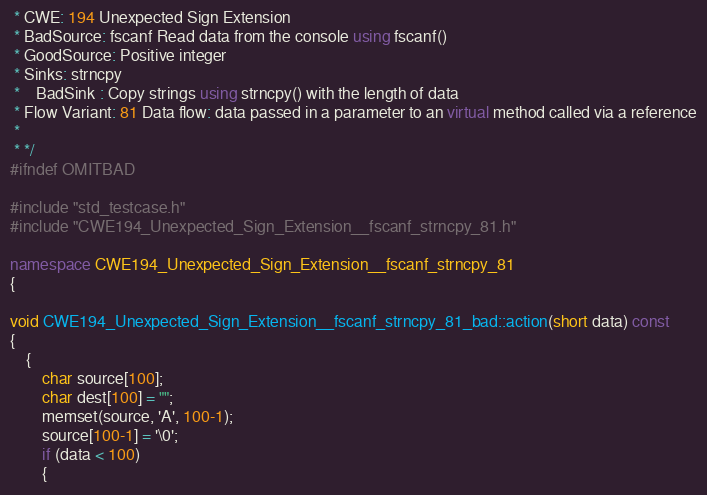Convert code to text. <code><loc_0><loc_0><loc_500><loc_500><_C++_> * CWE: 194 Unexpected Sign Extension
 * BadSource: fscanf Read data from the console using fscanf()
 * GoodSource: Positive integer
 * Sinks: strncpy
 *    BadSink : Copy strings using strncpy() with the length of data
 * Flow Variant: 81 Data flow: data passed in a parameter to an virtual method called via a reference
 *
 * */
#ifndef OMITBAD

#include "std_testcase.h"
#include "CWE194_Unexpected_Sign_Extension__fscanf_strncpy_81.h"

namespace CWE194_Unexpected_Sign_Extension__fscanf_strncpy_81
{

void CWE194_Unexpected_Sign_Extension__fscanf_strncpy_81_bad::action(short data) const
{
    {
        char source[100];
        char dest[100] = "";
        memset(source, 'A', 100-1);
        source[100-1] = '\0';
        if (data < 100)
        {</code> 